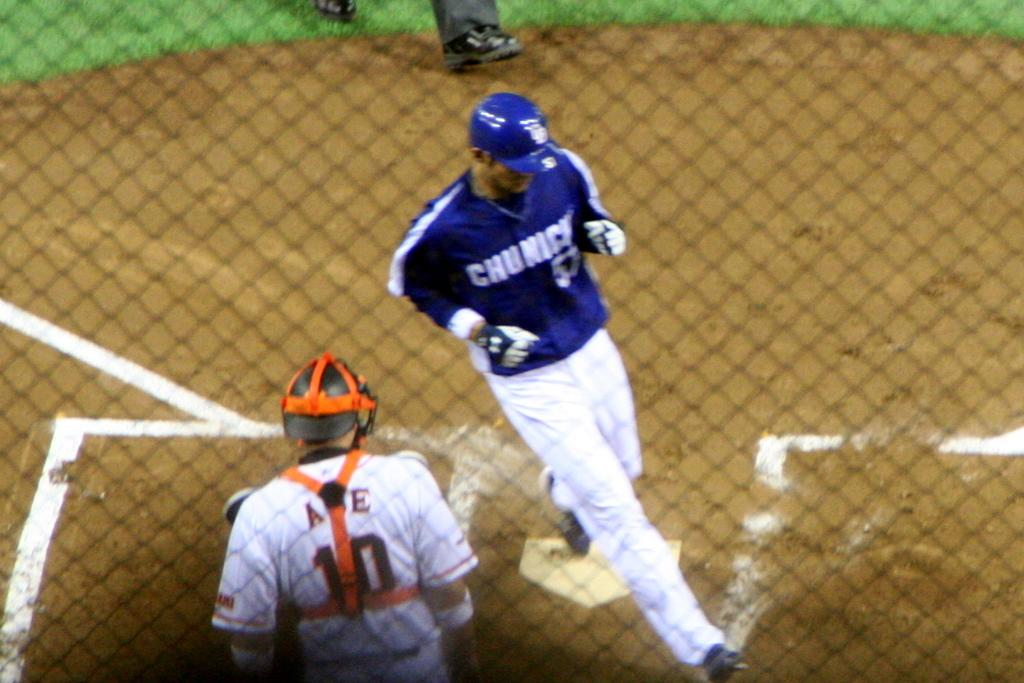<image>
Write a terse but informative summary of the picture. The baseball player for the team Chunichi jogs across home plate. 